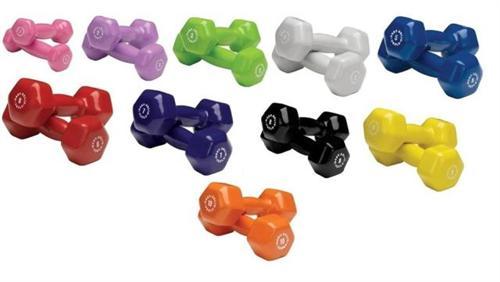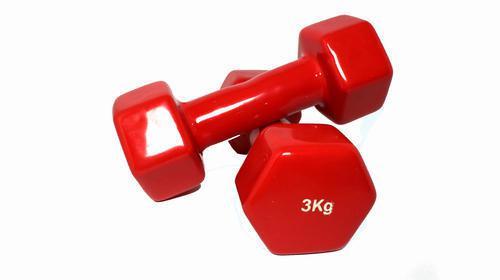The first image is the image on the left, the second image is the image on the right. Evaluate the accuracy of this statement regarding the images: "One image features at least 10 different colors of dumbbells.". Is it true? Answer yes or no. Yes. The first image is the image on the left, the second image is the image on the right. Examine the images to the left and right. Is the description "In at least one image there is a total of 12 weights." accurate? Answer yes or no. No. 